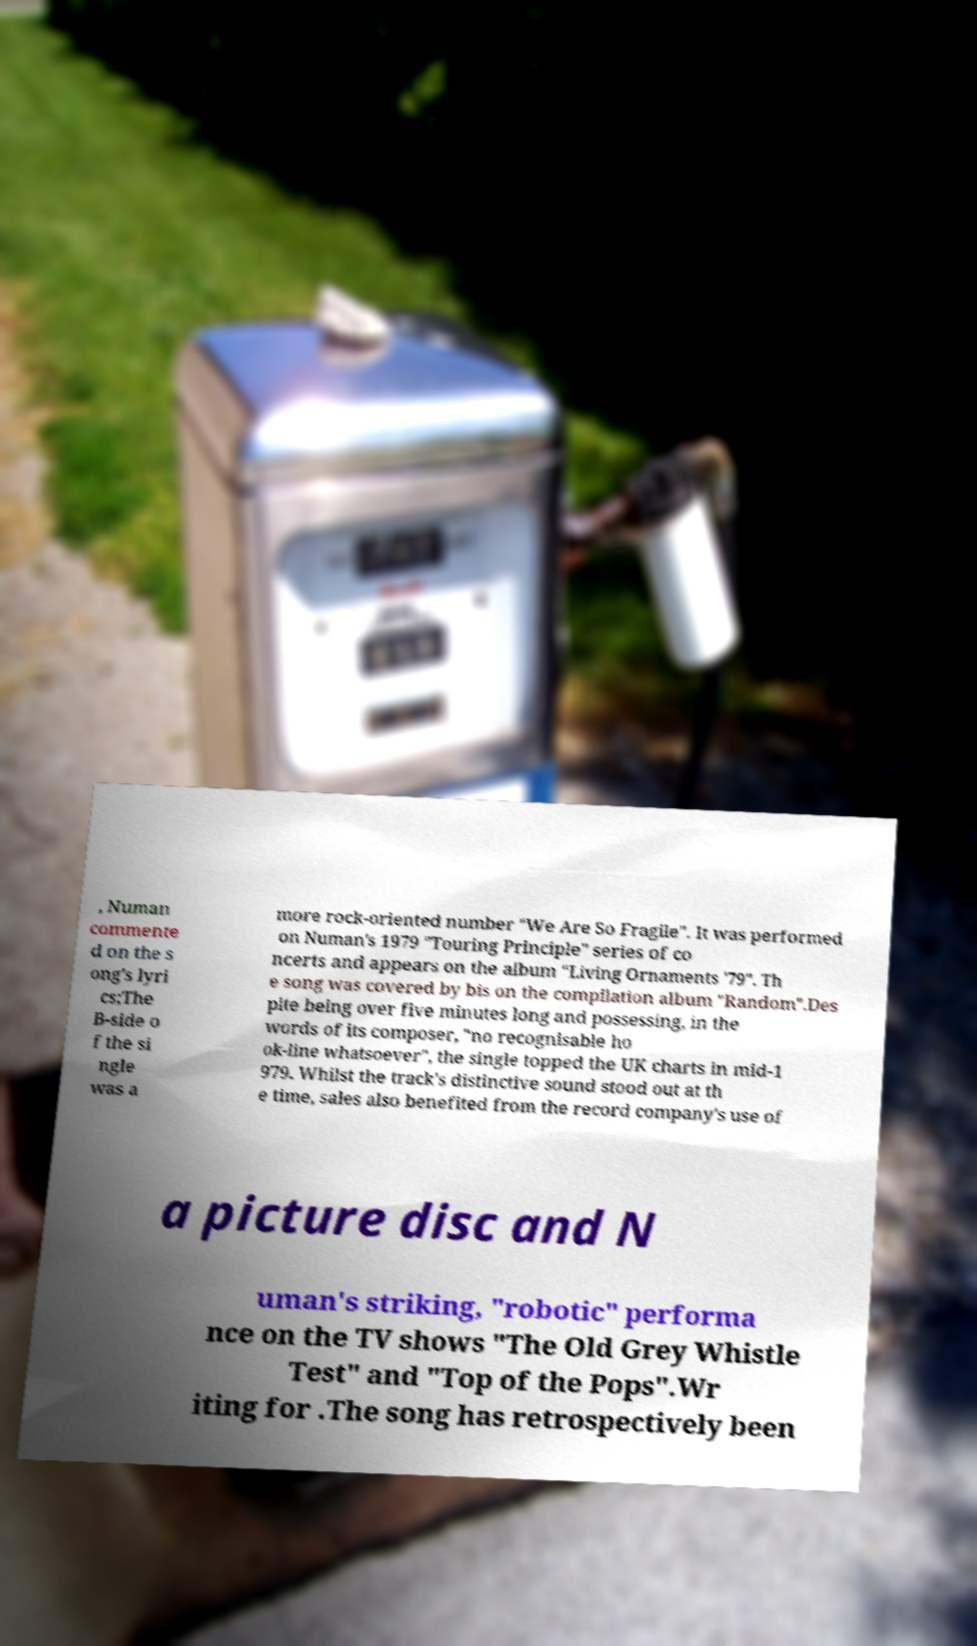For documentation purposes, I need the text within this image transcribed. Could you provide that? , Numan commente d on the s ong's lyri cs;The B-side o f the si ngle was a more rock-oriented number "We Are So Fragile". It was performed on Numan's 1979 "Touring Principle" series of co ncerts and appears on the album "Living Ornaments '79". Th e song was covered by bis on the compilation album "Random".Des pite being over five minutes long and possessing, in the words of its composer, "no recognisable ho ok-line whatsoever", the single topped the UK charts in mid-1 979. Whilst the track's distinctive sound stood out at th e time, sales also benefited from the record company's use of a picture disc and N uman's striking, "robotic" performa nce on the TV shows "The Old Grey Whistle Test" and "Top of the Pops".Wr iting for .The song has retrospectively been 